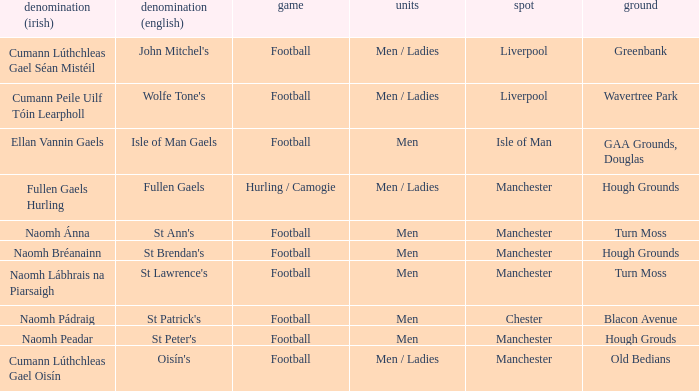What Pitch is located at Isle of Man? GAA Grounds, Douglas. 